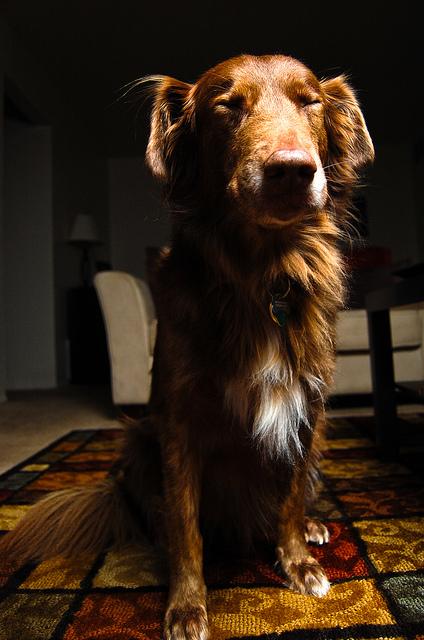Is this taken in sunlight?
Write a very short answer. No. Is this a short haired dog?
Answer briefly. No. What is on the dog's neck?
Quick response, please. Collar. What time of day is it?
Concise answer only. Night. What color is the dog?
Concise answer only. Brown. 